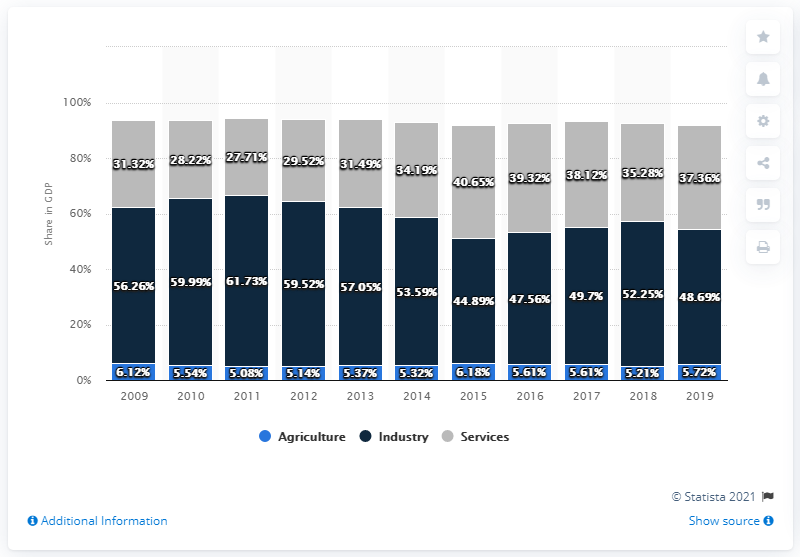Indicate a few pertinent items in this graphic. In 2019, the agriculture sector accounted for 5.72% of Azerbaijan's total gross domestic product. 